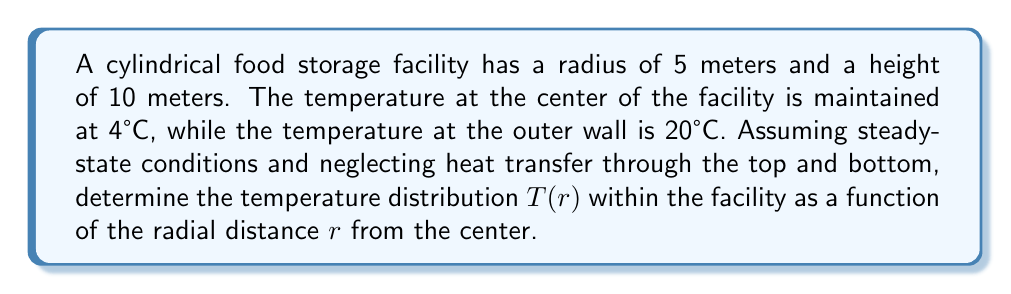Provide a solution to this math problem. To solve this problem, we'll use the steady-state heat equation in cylindrical coordinates:

1) The general form of the heat equation in cylindrical coordinates is:
   $$\frac{1}{r}\frac{\partial}{\partial r}\left(r\frac{\partial T}{\partial r}\right) + \frac{1}{r^2}\frac{\partial^2 T}{\partial \theta^2} + \frac{\partial^2 T}{\partial z^2} = 0$$

2) Since we're assuming steady-state conditions and neglecting heat transfer through the top and bottom, the equation simplifies to:
   $$\frac{1}{r}\frac{d}{dr}\left(r\frac{dT}{dr}\right) = 0$$

3) Integrating this equation once:
   $$r\frac{dT}{dr} = C_1$$

4) Integrating again:
   $$T(r) = C_1 \ln(r) + C_2$$

5) Now, we apply the boundary conditions:
   At $r = 0$, $T = 4°C$
   At $r = 5$, $T = 20°C$

6) Applying the first condition:
   $4 = C_1 \ln(0) + C_2$
   Since $\ln(0)$ is undefined, $C_1$ must be 0 for the equation to make sense at $r = 0$.
   Therefore, $C_2 = 4$

7) Applying the second condition:
   $20 = C_1 \ln(5) + 4$
   $C_1 = \frac{16}{\ln(5)}$

8) The final temperature distribution is:
   $$T(r) = \frac{16}{\ln(5)}\ln(r) + 4$$
Answer: $T(r) = \frac{16}{\ln(5)}\ln(r) + 4$ 